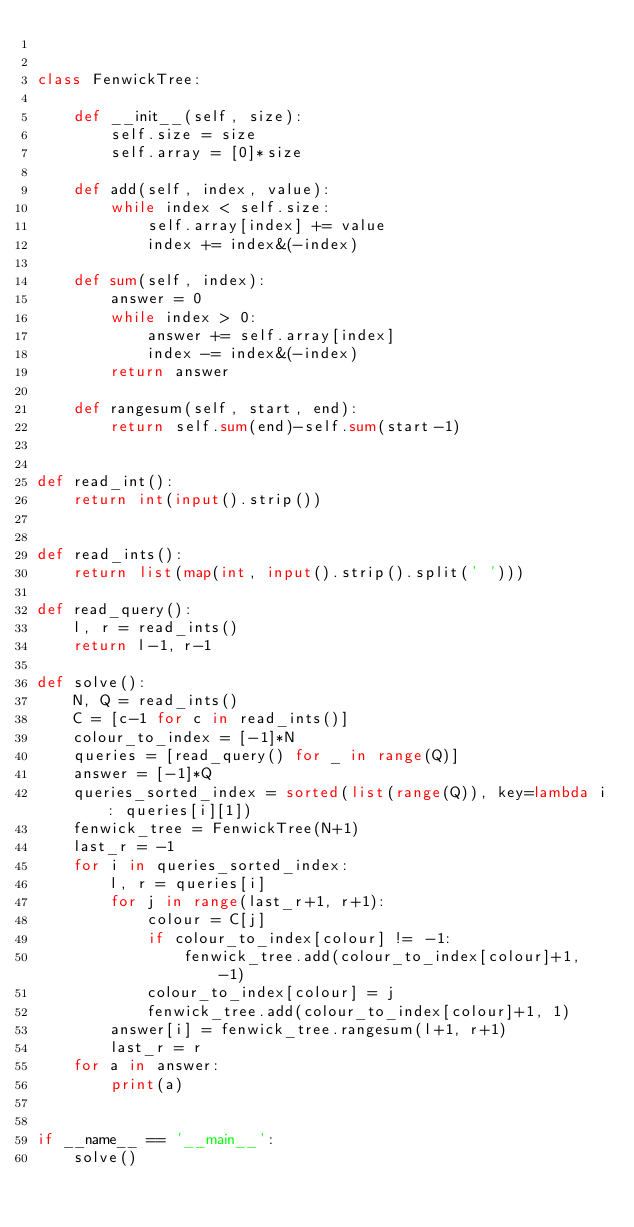Convert code to text. <code><loc_0><loc_0><loc_500><loc_500><_Python_>

class FenwickTree:

    def __init__(self, size):
        self.size = size
        self.array = [0]*size

    def add(self, index, value):
        while index < self.size:
            self.array[index] += value
            index += index&(-index)

    def sum(self, index):
        answer = 0
        while index > 0:
            answer += self.array[index]
            index -= index&(-index)
        return answer

    def rangesum(self, start, end):
        return self.sum(end)-self.sum(start-1)


def read_int():
    return int(input().strip())


def read_ints():
    return list(map(int, input().strip().split(' ')))

def read_query():
    l, r = read_ints()
    return l-1, r-1

def solve():
    N, Q = read_ints()
    C = [c-1 for c in read_ints()]
    colour_to_index = [-1]*N
    queries = [read_query() for _ in range(Q)]
    answer = [-1]*Q
    queries_sorted_index = sorted(list(range(Q)), key=lambda i: queries[i][1])
    fenwick_tree = FenwickTree(N+1)
    last_r = -1
    for i in queries_sorted_index:
        l, r = queries[i]
        for j in range(last_r+1, r+1):
            colour = C[j]
            if colour_to_index[colour] != -1:
                fenwick_tree.add(colour_to_index[colour]+1, -1)
            colour_to_index[colour] = j
            fenwick_tree.add(colour_to_index[colour]+1, 1)
        answer[i] = fenwick_tree.rangesum(l+1, r+1)
        last_r = r
    for a in answer:
        print(a)


if __name__ == '__main__':
    solve()
</code> 